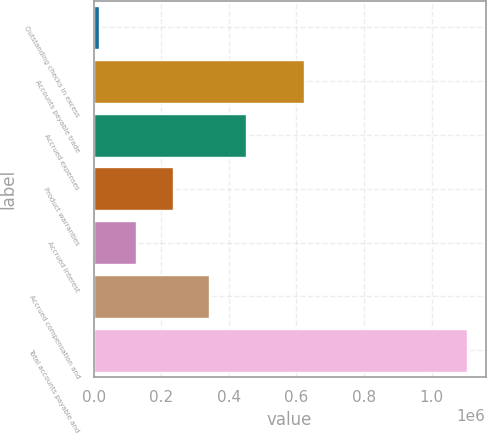<chart> <loc_0><loc_0><loc_500><loc_500><bar_chart><fcel>Outstanding checks in excess<fcel>Accounts payable trade<fcel>Accrued expenses<fcel>Product warranties<fcel>Accrued interest<fcel>Accrued compensation and<fcel>Total accounts payable and<nl><fcel>16083<fcel>622360<fcel>451453<fcel>233768<fcel>124926<fcel>342611<fcel>1.10451e+06<nl></chart> 